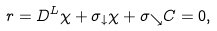<formula> <loc_0><loc_0><loc_500><loc_500>r = D ^ { L } \chi + \sigma _ { \downarrow } \chi + \sigma _ { \searrow } C = 0 ,</formula> 